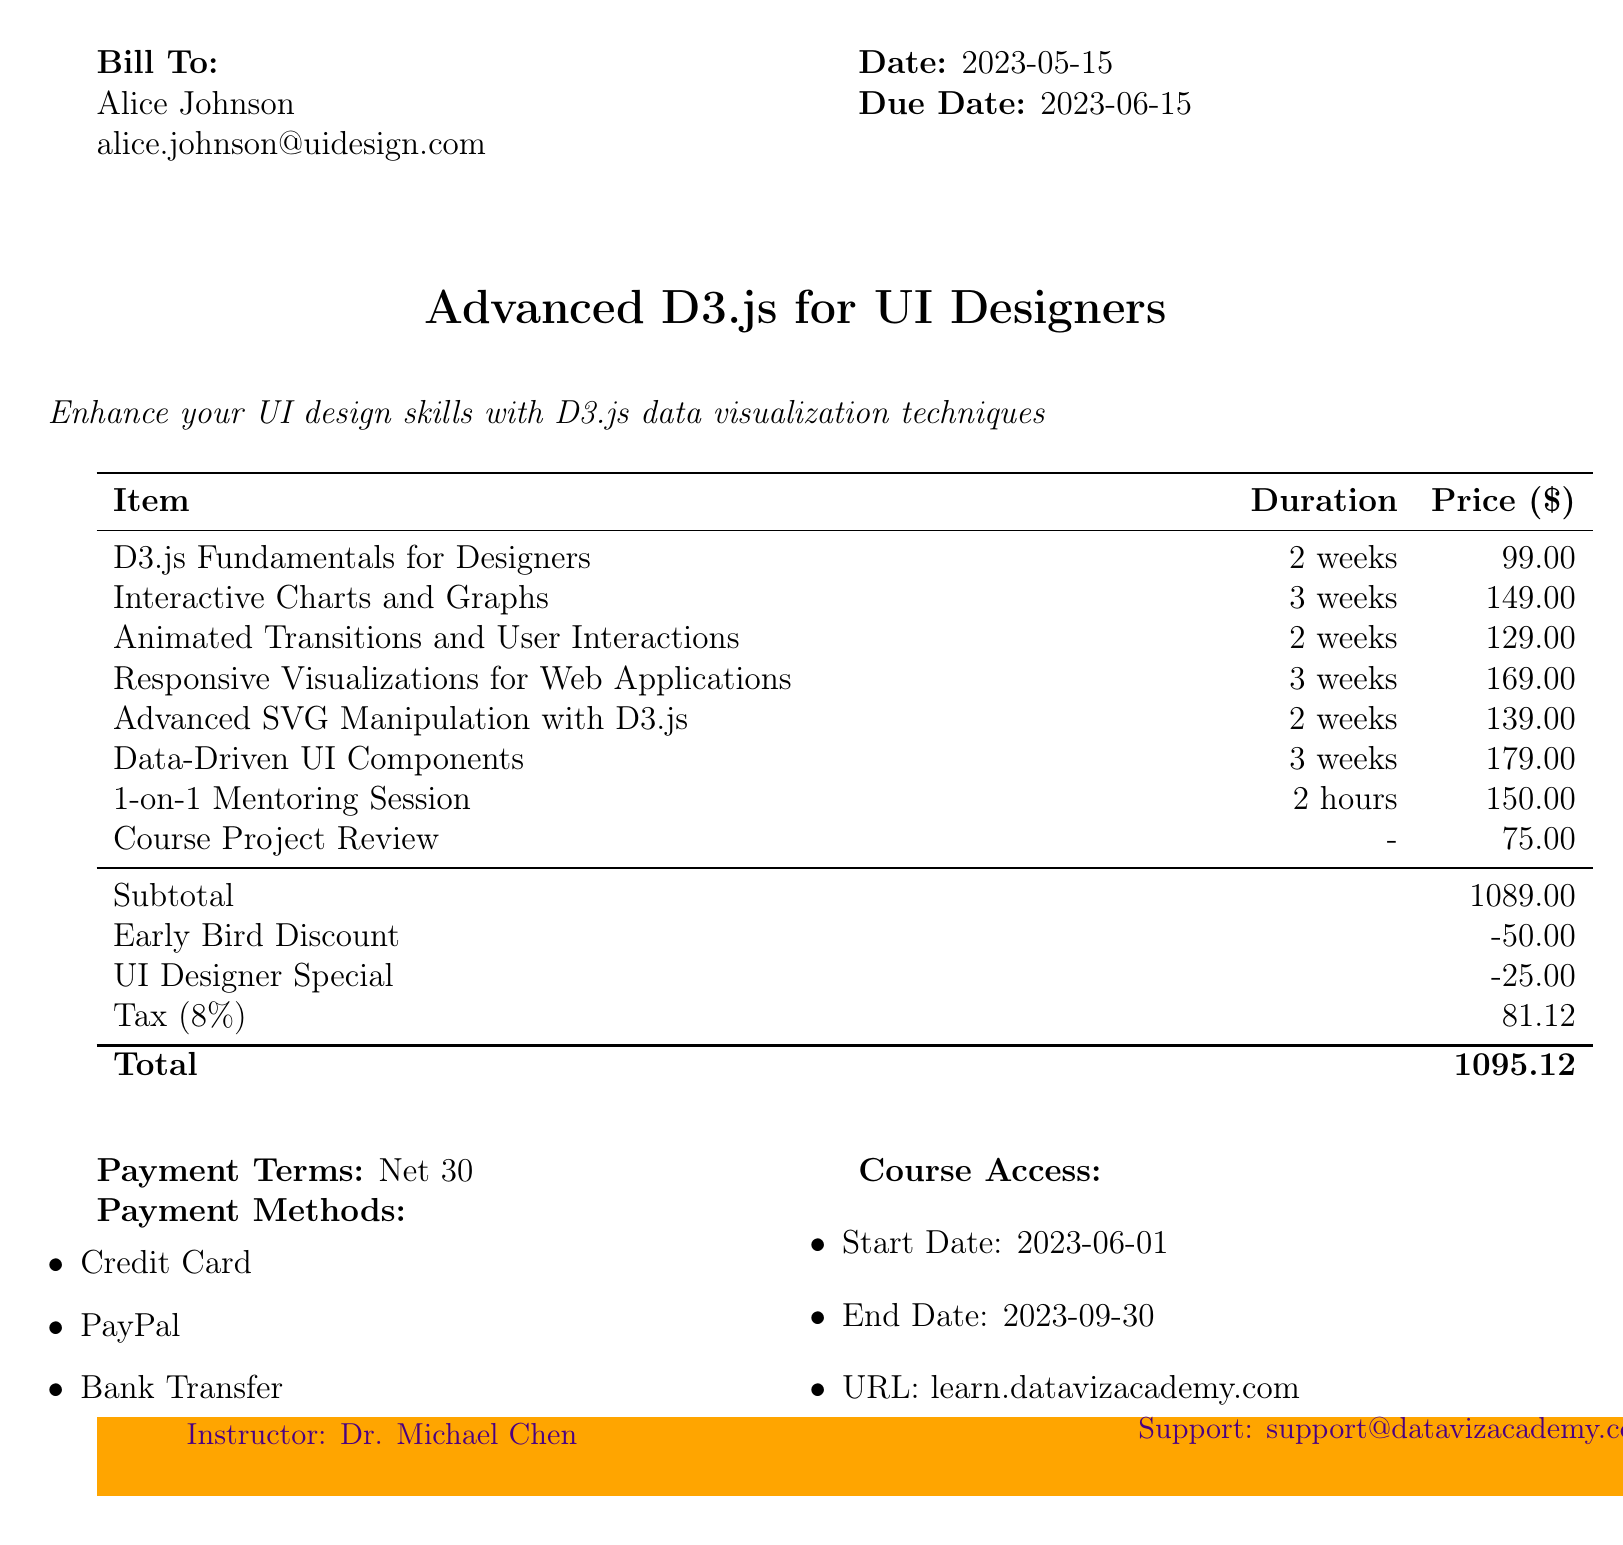What is the invoice number? The invoice number is listed at the top of the document, identifying this specific billing instance.
Answer: INV-D3JS-2023-0125 Who is the customer? The document clearly states the customer's name under the "Bill To" section.
Answer: Alice Johnson What is the total amount due? The "Total" section of the invoice specifies the complete amount that must be paid.
Answer: 1095.12 How many modules are listed in the course? By counting the items in the modules section, we can determine the total number of modules.
Answer: 6 What is the duration of the "Interactive Charts and Graphs" module? The duration is specified next to the module name in the breakdown table.
Answer: 3 weeks What discounts were applied to the invoice? The discounts can be found in the summary section, detailing the name and amount of each discount.
Answer: Early Bird Discount, UI Designer Special What is the tax rate applied to the invoice? The tax rate is indicated in the document as a percentage in the pricing summary.
Answer: 8% Who is the instructor for the course? The instructor's name is noted at the bottom of the document.
Answer: Dr. Michael Chen What payment methods are accepted? The acceptable payment methods are listed in the document, providing the options for payment.
Answer: Credit Card, PayPal, Bank Transfer 